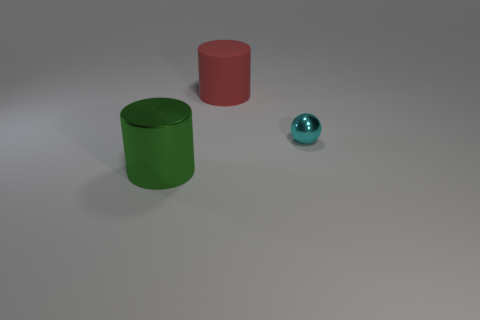Add 3 tiny balls. How many objects exist? 6 Subtract all cylinders. How many objects are left? 1 Subtract all gray balls. Subtract all big metal cylinders. How many objects are left? 2 Add 2 big matte cylinders. How many big matte cylinders are left? 3 Add 1 tiny metal things. How many tiny metal things exist? 2 Subtract 0 green blocks. How many objects are left? 3 